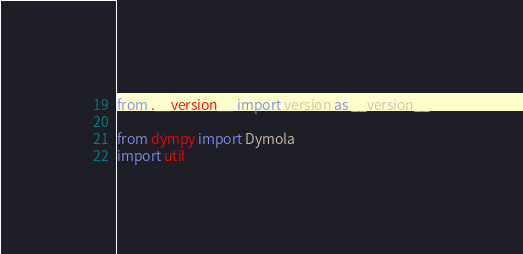Convert code to text. <code><loc_0><loc_0><loc_500><loc_500><_Python_>from .__version__ import version as __version__

from dympy import Dymola
import util</code> 